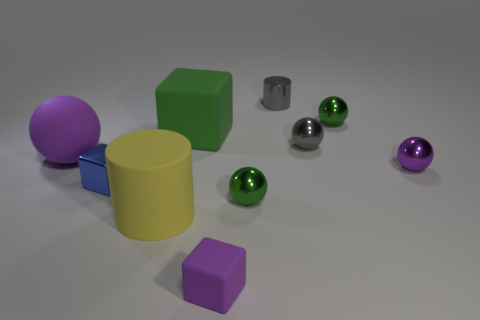Subtract all purple spheres. How many spheres are left? 3 Subtract all cyan blocks. How many purple balls are left? 2 Subtract 1 cylinders. How many cylinders are left? 1 Subtract all green spheres. How many spheres are left? 3 Subtract all blocks. How many objects are left? 7 Subtract all metallic things. Subtract all tiny purple metallic objects. How many objects are left? 3 Add 6 tiny spheres. How many tiny spheres are left? 10 Add 1 purple metal spheres. How many purple metal spheres exist? 2 Subtract 0 gray cubes. How many objects are left? 10 Subtract all yellow spheres. Subtract all gray cylinders. How many spheres are left? 5 